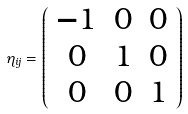<formula> <loc_0><loc_0><loc_500><loc_500>\eta _ { i j } = \left ( \begin{array} { c c c } - 1 & 0 & 0 \\ 0 & 1 & 0 \\ 0 & 0 & 1 \end{array} \right )</formula> 